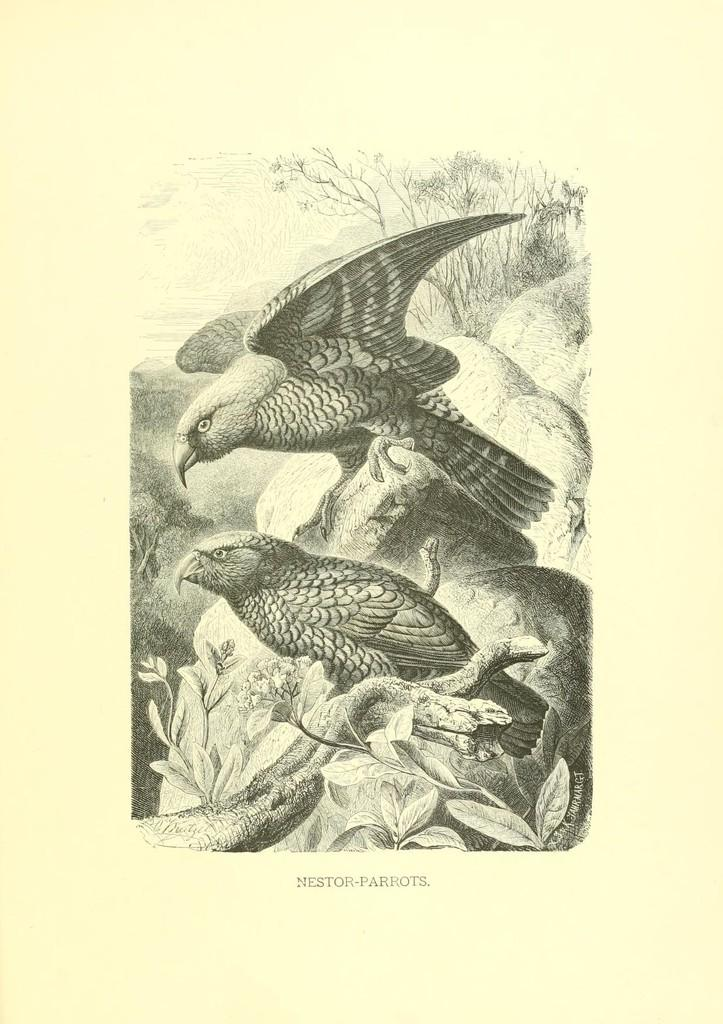What is present on the paper in the image? The content of the paper cannot be determined from the image. Where are the birds located in the image? Two birds are sitting on a rock in the image. What part of a plant can be seen in the image? The stem of a plant is visible in the image. What can be seen in the distance in the image? There are trees and the sky visible in the background of the image. What is the profit margin of the birds in the image? There is no information about profit margins in the image, as it features birds sitting on a rock and other natural elements. Can you provide more detail about the error in the image? There is no error present in the image; it is a clear and accurate representation of the scene. 